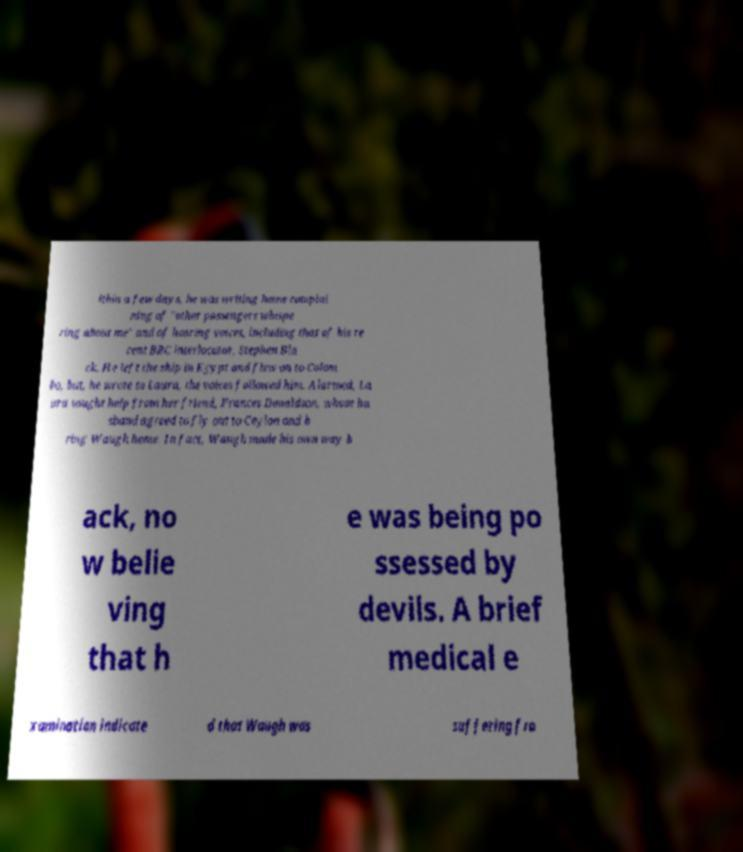Can you read and provide the text displayed in the image?This photo seems to have some interesting text. Can you extract and type it out for me? ithin a few days, he was writing home complai ning of "other passengers whispe ring about me" and of hearing voices, including that of his re cent BBC interlocutor, Stephen Bla ck. He left the ship in Egypt and flew on to Colom bo, but, he wrote to Laura, the voices followed him. Alarmed, La ura sought help from her friend, Frances Donaldson, whose hu sband agreed to fly out to Ceylon and b ring Waugh home. In fact, Waugh made his own way b ack, no w belie ving that h e was being po ssessed by devils. A brief medical e xamination indicate d that Waugh was suffering fro 